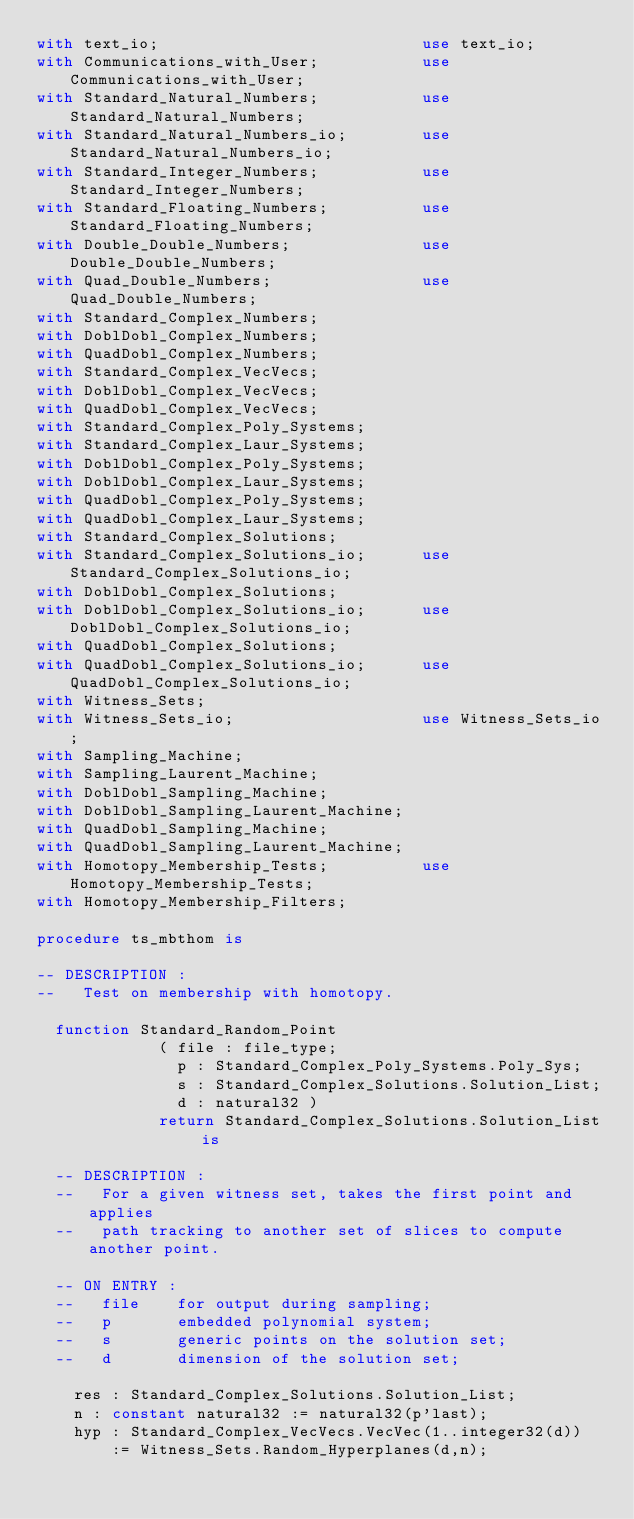Convert code to text. <code><loc_0><loc_0><loc_500><loc_500><_Ada_>with text_io;                            use text_io;
with Communications_with_User;           use Communications_with_User;
with Standard_Natural_Numbers;           use Standard_Natural_Numbers;
with Standard_Natural_Numbers_io;        use Standard_Natural_Numbers_io;
with Standard_Integer_Numbers;           use Standard_Integer_Numbers;
with Standard_Floating_Numbers;          use Standard_Floating_Numbers;
with Double_Double_Numbers;              use Double_Double_Numbers;
with Quad_Double_Numbers;                use Quad_Double_Numbers;
with Standard_Complex_Numbers;
with DoblDobl_Complex_Numbers;
with QuadDobl_Complex_Numbers;
with Standard_Complex_VecVecs;
with DoblDobl_Complex_VecVecs;
with QuadDobl_Complex_VecVecs;
with Standard_Complex_Poly_Systems;
with Standard_Complex_Laur_Systems;
with DoblDobl_Complex_Poly_Systems;
with DoblDobl_Complex_Laur_Systems;
with QuadDobl_Complex_Poly_Systems;
with QuadDobl_Complex_Laur_Systems;
with Standard_Complex_Solutions;
with Standard_Complex_Solutions_io;      use Standard_Complex_Solutions_io;
with DoblDobl_Complex_Solutions;
with DoblDobl_Complex_Solutions_io;      use DoblDobl_Complex_Solutions_io;
with QuadDobl_Complex_Solutions;
with QuadDobl_Complex_Solutions_io;      use QuadDobl_Complex_Solutions_io;
with Witness_Sets;
with Witness_Sets_io;                    use Witness_Sets_io;
with Sampling_Machine;
with Sampling_Laurent_Machine;
with DoblDobl_Sampling_Machine;
with DoblDobl_Sampling_Laurent_Machine;
with QuadDobl_Sampling_Machine;
with QuadDobl_Sampling_Laurent_Machine;
with Homotopy_Membership_Tests;          use Homotopy_Membership_Tests;
with Homotopy_Membership_Filters;

procedure ts_mbthom is

-- DESCRIPTION :
--   Test on membership with homotopy.

  function Standard_Random_Point
             ( file : file_type;
               p : Standard_Complex_Poly_Systems.Poly_Sys;
               s : Standard_Complex_Solutions.Solution_List;
               d : natural32 )
             return Standard_Complex_Solutions.Solution_List is

  -- DESCRIPTION :
  --   For a given witness set, takes the first point and applies
  --   path tracking to another set of slices to compute another point.

  -- ON ENTRY :
  --   file    for output during sampling;
  --   p       embedded polynomial system;
  --   s       generic points on the solution set;
  --   d       dimension of the solution set;

    res : Standard_Complex_Solutions.Solution_List;
    n : constant natural32 := natural32(p'last);
    hyp : Standard_Complex_VecVecs.VecVec(1..integer32(d))
        := Witness_Sets.Random_Hyperplanes(d,n);</code> 